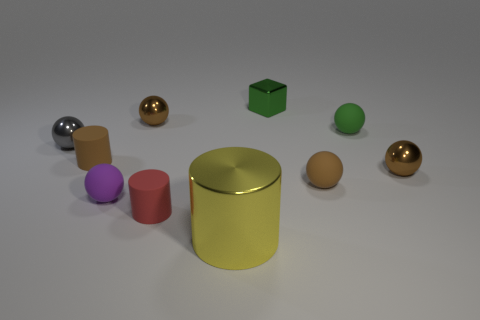Is the size of the gray thing the same as the shiny cylinder?
Your answer should be very brief. No. What number of things are rubber balls that are to the right of the yellow thing or tiny brown cylinders?
Your response must be concise. 3. The green thing that is behind the tiny brown shiny thing to the left of the small green metallic thing is made of what material?
Give a very brief answer. Metal. Is there a red matte thing of the same shape as the green shiny object?
Ensure brevity in your answer.  No. There is a gray metallic sphere; does it have the same size as the brown ball left of the yellow cylinder?
Keep it short and to the point. Yes. How many things are either rubber spheres that are left of the green matte sphere or small things that are to the left of the brown rubber cylinder?
Make the answer very short. 3. Are there more small rubber objects behind the brown matte cylinder than small brown blocks?
Provide a short and direct response. Yes. How many purple things have the same size as the green rubber sphere?
Give a very brief answer. 1. There is a brown matte thing that is to the right of the metal cylinder; does it have the same size as the brown shiny thing to the right of the big thing?
Your answer should be very brief. Yes. There is a cylinder that is in front of the red matte cylinder; how big is it?
Give a very brief answer. Large. 